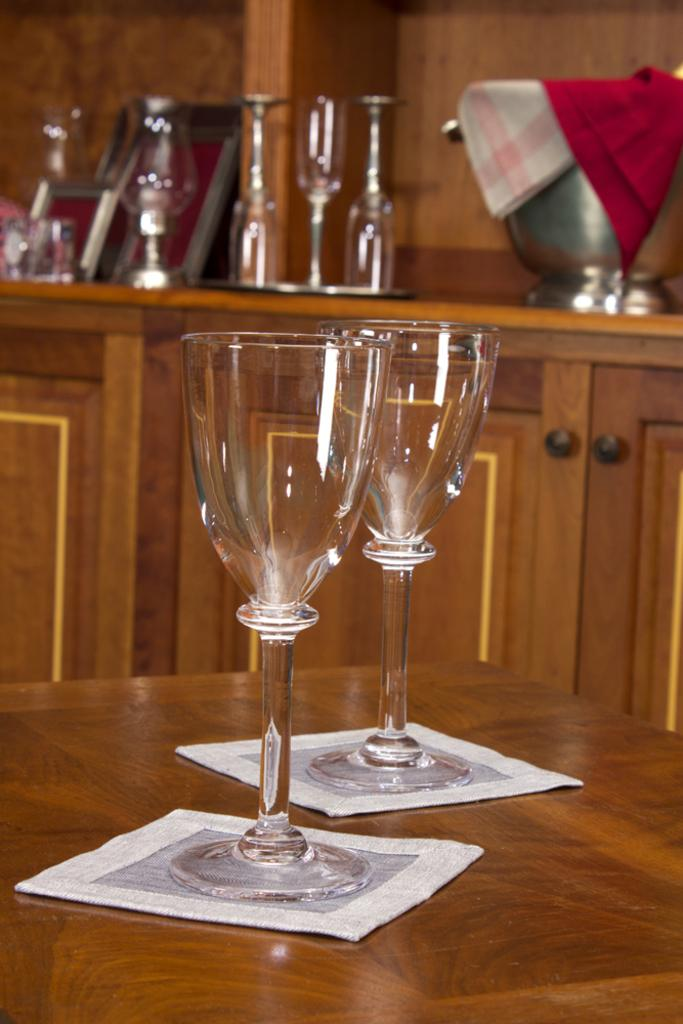How many glasses can be seen in the image? There are two glasses in the image. What is the glasses placed on? The glasses are placed on a white object. Where is the white object located? The white object is on a table. Can you describe any other objects visible in the background of the image? Unfortunately, the provided facts do not give any information about other objects in the background. What reason do the bikes have for being in the image? There are no bikes present in the image, so there is no reason for them to be in the image. 